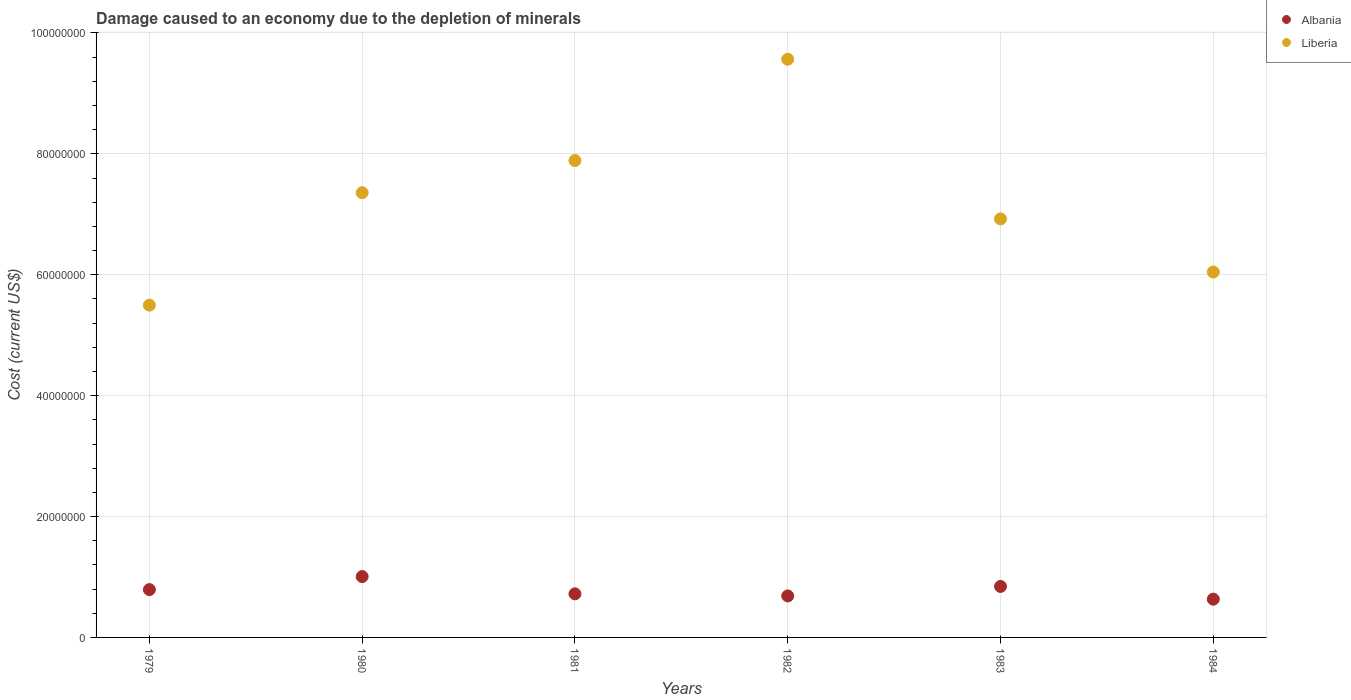How many different coloured dotlines are there?
Keep it short and to the point. 2. Is the number of dotlines equal to the number of legend labels?
Your response must be concise. Yes. What is the cost of damage caused due to the depletion of minerals in Albania in 1983?
Offer a terse response. 8.43e+06. Across all years, what is the maximum cost of damage caused due to the depletion of minerals in Albania?
Offer a terse response. 1.01e+07. Across all years, what is the minimum cost of damage caused due to the depletion of minerals in Liberia?
Offer a terse response. 5.50e+07. In which year was the cost of damage caused due to the depletion of minerals in Liberia maximum?
Make the answer very short. 1982. In which year was the cost of damage caused due to the depletion of minerals in Albania minimum?
Your answer should be very brief. 1984. What is the total cost of damage caused due to the depletion of minerals in Albania in the graph?
Your answer should be compact. 4.68e+07. What is the difference between the cost of damage caused due to the depletion of minerals in Liberia in 1981 and that in 1983?
Keep it short and to the point. 9.65e+06. What is the difference between the cost of damage caused due to the depletion of minerals in Liberia in 1980 and the cost of damage caused due to the depletion of minerals in Albania in 1982?
Offer a very short reply. 6.67e+07. What is the average cost of damage caused due to the depletion of minerals in Liberia per year?
Ensure brevity in your answer.  7.21e+07. In the year 1981, what is the difference between the cost of damage caused due to the depletion of minerals in Albania and cost of damage caused due to the depletion of minerals in Liberia?
Your answer should be very brief. -7.17e+07. In how many years, is the cost of damage caused due to the depletion of minerals in Albania greater than 16000000 US$?
Offer a very short reply. 0. What is the ratio of the cost of damage caused due to the depletion of minerals in Liberia in 1980 to that in 1981?
Your response must be concise. 0.93. Is the cost of damage caused due to the depletion of minerals in Liberia in 1979 less than that in 1984?
Provide a succinct answer. Yes. Is the difference between the cost of damage caused due to the depletion of minerals in Albania in 1979 and 1984 greater than the difference between the cost of damage caused due to the depletion of minerals in Liberia in 1979 and 1984?
Your answer should be very brief. Yes. What is the difference between the highest and the second highest cost of damage caused due to the depletion of minerals in Liberia?
Keep it short and to the point. 1.68e+07. What is the difference between the highest and the lowest cost of damage caused due to the depletion of minerals in Albania?
Keep it short and to the point. 3.74e+06. In how many years, is the cost of damage caused due to the depletion of minerals in Albania greater than the average cost of damage caused due to the depletion of minerals in Albania taken over all years?
Offer a terse response. 3. Is the sum of the cost of damage caused due to the depletion of minerals in Liberia in 1979 and 1980 greater than the maximum cost of damage caused due to the depletion of minerals in Albania across all years?
Provide a short and direct response. Yes. Does the cost of damage caused due to the depletion of minerals in Albania monotonically increase over the years?
Keep it short and to the point. No. Is the cost of damage caused due to the depletion of minerals in Liberia strictly less than the cost of damage caused due to the depletion of minerals in Albania over the years?
Offer a terse response. No. How many dotlines are there?
Ensure brevity in your answer.  2. Are the values on the major ticks of Y-axis written in scientific E-notation?
Your answer should be very brief. No. How are the legend labels stacked?
Ensure brevity in your answer.  Vertical. What is the title of the graph?
Provide a short and direct response. Damage caused to an economy due to the depletion of minerals. What is the label or title of the X-axis?
Your answer should be very brief. Years. What is the label or title of the Y-axis?
Provide a short and direct response. Cost (current US$). What is the Cost (current US$) of Albania in 1979?
Your response must be concise. 7.91e+06. What is the Cost (current US$) in Liberia in 1979?
Make the answer very short. 5.50e+07. What is the Cost (current US$) of Albania in 1980?
Your answer should be very brief. 1.01e+07. What is the Cost (current US$) in Liberia in 1980?
Your response must be concise. 7.36e+07. What is the Cost (current US$) in Albania in 1981?
Your answer should be very brief. 7.21e+06. What is the Cost (current US$) in Liberia in 1981?
Offer a very short reply. 7.89e+07. What is the Cost (current US$) of Albania in 1982?
Provide a short and direct response. 6.87e+06. What is the Cost (current US$) of Liberia in 1982?
Keep it short and to the point. 9.57e+07. What is the Cost (current US$) of Albania in 1983?
Give a very brief answer. 8.43e+06. What is the Cost (current US$) in Liberia in 1983?
Ensure brevity in your answer.  6.92e+07. What is the Cost (current US$) in Albania in 1984?
Give a very brief answer. 6.33e+06. What is the Cost (current US$) of Liberia in 1984?
Offer a terse response. 6.05e+07. Across all years, what is the maximum Cost (current US$) of Albania?
Your answer should be very brief. 1.01e+07. Across all years, what is the maximum Cost (current US$) of Liberia?
Ensure brevity in your answer.  9.57e+07. Across all years, what is the minimum Cost (current US$) of Albania?
Offer a terse response. 6.33e+06. Across all years, what is the minimum Cost (current US$) of Liberia?
Provide a succinct answer. 5.50e+07. What is the total Cost (current US$) of Albania in the graph?
Provide a succinct answer. 4.68e+07. What is the total Cost (current US$) in Liberia in the graph?
Offer a terse response. 4.33e+08. What is the difference between the Cost (current US$) in Albania in 1979 and that in 1980?
Your answer should be compact. -2.16e+06. What is the difference between the Cost (current US$) of Liberia in 1979 and that in 1980?
Provide a short and direct response. -1.86e+07. What is the difference between the Cost (current US$) of Albania in 1979 and that in 1981?
Provide a succinct answer. 7.00e+05. What is the difference between the Cost (current US$) of Liberia in 1979 and that in 1981?
Give a very brief answer. -2.39e+07. What is the difference between the Cost (current US$) in Albania in 1979 and that in 1982?
Your answer should be very brief. 1.05e+06. What is the difference between the Cost (current US$) in Liberia in 1979 and that in 1982?
Keep it short and to the point. -4.07e+07. What is the difference between the Cost (current US$) in Albania in 1979 and that in 1983?
Make the answer very short. -5.22e+05. What is the difference between the Cost (current US$) in Liberia in 1979 and that in 1983?
Offer a terse response. -1.43e+07. What is the difference between the Cost (current US$) of Albania in 1979 and that in 1984?
Keep it short and to the point. 1.58e+06. What is the difference between the Cost (current US$) of Liberia in 1979 and that in 1984?
Ensure brevity in your answer.  -5.48e+06. What is the difference between the Cost (current US$) of Albania in 1980 and that in 1981?
Keep it short and to the point. 2.86e+06. What is the difference between the Cost (current US$) in Liberia in 1980 and that in 1981?
Provide a succinct answer. -5.32e+06. What is the difference between the Cost (current US$) in Albania in 1980 and that in 1982?
Your answer should be compact. 3.20e+06. What is the difference between the Cost (current US$) in Liberia in 1980 and that in 1982?
Your answer should be very brief. -2.21e+07. What is the difference between the Cost (current US$) in Albania in 1980 and that in 1983?
Provide a short and direct response. 1.63e+06. What is the difference between the Cost (current US$) of Liberia in 1980 and that in 1983?
Your answer should be very brief. 4.33e+06. What is the difference between the Cost (current US$) in Albania in 1980 and that in 1984?
Make the answer very short. 3.74e+06. What is the difference between the Cost (current US$) in Liberia in 1980 and that in 1984?
Keep it short and to the point. 1.31e+07. What is the difference between the Cost (current US$) in Albania in 1981 and that in 1982?
Give a very brief answer. 3.46e+05. What is the difference between the Cost (current US$) of Liberia in 1981 and that in 1982?
Your answer should be very brief. -1.68e+07. What is the difference between the Cost (current US$) of Albania in 1981 and that in 1983?
Provide a short and direct response. -1.22e+06. What is the difference between the Cost (current US$) of Liberia in 1981 and that in 1983?
Ensure brevity in your answer.  9.65e+06. What is the difference between the Cost (current US$) in Albania in 1981 and that in 1984?
Give a very brief answer. 8.84e+05. What is the difference between the Cost (current US$) in Liberia in 1981 and that in 1984?
Provide a short and direct response. 1.84e+07. What is the difference between the Cost (current US$) in Albania in 1982 and that in 1983?
Ensure brevity in your answer.  -1.57e+06. What is the difference between the Cost (current US$) in Liberia in 1982 and that in 1983?
Offer a terse response. 2.64e+07. What is the difference between the Cost (current US$) in Albania in 1982 and that in 1984?
Your answer should be compact. 5.38e+05. What is the difference between the Cost (current US$) of Liberia in 1982 and that in 1984?
Give a very brief answer. 3.52e+07. What is the difference between the Cost (current US$) in Albania in 1983 and that in 1984?
Provide a succinct answer. 2.11e+06. What is the difference between the Cost (current US$) of Liberia in 1983 and that in 1984?
Make the answer very short. 8.79e+06. What is the difference between the Cost (current US$) of Albania in 1979 and the Cost (current US$) of Liberia in 1980?
Offer a very short reply. -6.57e+07. What is the difference between the Cost (current US$) of Albania in 1979 and the Cost (current US$) of Liberia in 1981?
Give a very brief answer. -7.10e+07. What is the difference between the Cost (current US$) of Albania in 1979 and the Cost (current US$) of Liberia in 1982?
Your answer should be very brief. -8.77e+07. What is the difference between the Cost (current US$) in Albania in 1979 and the Cost (current US$) in Liberia in 1983?
Offer a very short reply. -6.13e+07. What is the difference between the Cost (current US$) of Albania in 1979 and the Cost (current US$) of Liberia in 1984?
Make the answer very short. -5.25e+07. What is the difference between the Cost (current US$) of Albania in 1980 and the Cost (current US$) of Liberia in 1981?
Keep it short and to the point. -6.88e+07. What is the difference between the Cost (current US$) in Albania in 1980 and the Cost (current US$) in Liberia in 1982?
Offer a terse response. -8.56e+07. What is the difference between the Cost (current US$) in Albania in 1980 and the Cost (current US$) in Liberia in 1983?
Your response must be concise. -5.92e+07. What is the difference between the Cost (current US$) in Albania in 1980 and the Cost (current US$) in Liberia in 1984?
Ensure brevity in your answer.  -5.04e+07. What is the difference between the Cost (current US$) in Albania in 1981 and the Cost (current US$) in Liberia in 1982?
Make the answer very short. -8.84e+07. What is the difference between the Cost (current US$) in Albania in 1981 and the Cost (current US$) in Liberia in 1983?
Provide a short and direct response. -6.20e+07. What is the difference between the Cost (current US$) in Albania in 1981 and the Cost (current US$) in Liberia in 1984?
Keep it short and to the point. -5.32e+07. What is the difference between the Cost (current US$) of Albania in 1982 and the Cost (current US$) of Liberia in 1983?
Your answer should be compact. -6.24e+07. What is the difference between the Cost (current US$) in Albania in 1982 and the Cost (current US$) in Liberia in 1984?
Make the answer very short. -5.36e+07. What is the difference between the Cost (current US$) of Albania in 1983 and the Cost (current US$) of Liberia in 1984?
Your answer should be compact. -5.20e+07. What is the average Cost (current US$) in Albania per year?
Your answer should be compact. 7.80e+06. What is the average Cost (current US$) of Liberia per year?
Keep it short and to the point. 7.21e+07. In the year 1979, what is the difference between the Cost (current US$) of Albania and Cost (current US$) of Liberia?
Keep it short and to the point. -4.71e+07. In the year 1980, what is the difference between the Cost (current US$) in Albania and Cost (current US$) in Liberia?
Your response must be concise. -6.35e+07. In the year 1981, what is the difference between the Cost (current US$) in Albania and Cost (current US$) in Liberia?
Ensure brevity in your answer.  -7.17e+07. In the year 1982, what is the difference between the Cost (current US$) in Albania and Cost (current US$) in Liberia?
Ensure brevity in your answer.  -8.88e+07. In the year 1983, what is the difference between the Cost (current US$) of Albania and Cost (current US$) of Liberia?
Keep it short and to the point. -6.08e+07. In the year 1984, what is the difference between the Cost (current US$) in Albania and Cost (current US$) in Liberia?
Provide a succinct answer. -5.41e+07. What is the ratio of the Cost (current US$) in Albania in 1979 to that in 1980?
Your response must be concise. 0.79. What is the ratio of the Cost (current US$) in Liberia in 1979 to that in 1980?
Your response must be concise. 0.75. What is the ratio of the Cost (current US$) in Albania in 1979 to that in 1981?
Provide a succinct answer. 1.1. What is the ratio of the Cost (current US$) in Liberia in 1979 to that in 1981?
Make the answer very short. 0.7. What is the ratio of the Cost (current US$) in Albania in 1979 to that in 1982?
Your answer should be compact. 1.15. What is the ratio of the Cost (current US$) in Liberia in 1979 to that in 1982?
Your answer should be very brief. 0.57. What is the ratio of the Cost (current US$) in Albania in 1979 to that in 1983?
Offer a terse response. 0.94. What is the ratio of the Cost (current US$) in Liberia in 1979 to that in 1983?
Provide a succinct answer. 0.79. What is the ratio of the Cost (current US$) of Albania in 1979 to that in 1984?
Give a very brief answer. 1.25. What is the ratio of the Cost (current US$) of Liberia in 1979 to that in 1984?
Make the answer very short. 0.91. What is the ratio of the Cost (current US$) in Albania in 1980 to that in 1981?
Offer a very short reply. 1.4. What is the ratio of the Cost (current US$) in Liberia in 1980 to that in 1981?
Make the answer very short. 0.93. What is the ratio of the Cost (current US$) of Albania in 1980 to that in 1982?
Ensure brevity in your answer.  1.47. What is the ratio of the Cost (current US$) in Liberia in 1980 to that in 1982?
Provide a succinct answer. 0.77. What is the ratio of the Cost (current US$) in Albania in 1980 to that in 1983?
Offer a terse response. 1.19. What is the ratio of the Cost (current US$) in Albania in 1980 to that in 1984?
Ensure brevity in your answer.  1.59. What is the ratio of the Cost (current US$) of Liberia in 1980 to that in 1984?
Give a very brief answer. 1.22. What is the ratio of the Cost (current US$) of Albania in 1981 to that in 1982?
Make the answer very short. 1.05. What is the ratio of the Cost (current US$) of Liberia in 1981 to that in 1982?
Your answer should be very brief. 0.82. What is the ratio of the Cost (current US$) in Albania in 1981 to that in 1983?
Your answer should be compact. 0.86. What is the ratio of the Cost (current US$) of Liberia in 1981 to that in 1983?
Offer a very short reply. 1.14. What is the ratio of the Cost (current US$) of Albania in 1981 to that in 1984?
Give a very brief answer. 1.14. What is the ratio of the Cost (current US$) in Liberia in 1981 to that in 1984?
Offer a very short reply. 1.31. What is the ratio of the Cost (current US$) of Albania in 1982 to that in 1983?
Your answer should be very brief. 0.81. What is the ratio of the Cost (current US$) in Liberia in 1982 to that in 1983?
Offer a very short reply. 1.38. What is the ratio of the Cost (current US$) in Albania in 1982 to that in 1984?
Make the answer very short. 1.08. What is the ratio of the Cost (current US$) of Liberia in 1982 to that in 1984?
Your response must be concise. 1.58. What is the ratio of the Cost (current US$) in Albania in 1983 to that in 1984?
Your response must be concise. 1.33. What is the ratio of the Cost (current US$) in Liberia in 1983 to that in 1984?
Make the answer very short. 1.15. What is the difference between the highest and the second highest Cost (current US$) of Albania?
Offer a terse response. 1.63e+06. What is the difference between the highest and the second highest Cost (current US$) of Liberia?
Your response must be concise. 1.68e+07. What is the difference between the highest and the lowest Cost (current US$) in Albania?
Keep it short and to the point. 3.74e+06. What is the difference between the highest and the lowest Cost (current US$) of Liberia?
Make the answer very short. 4.07e+07. 